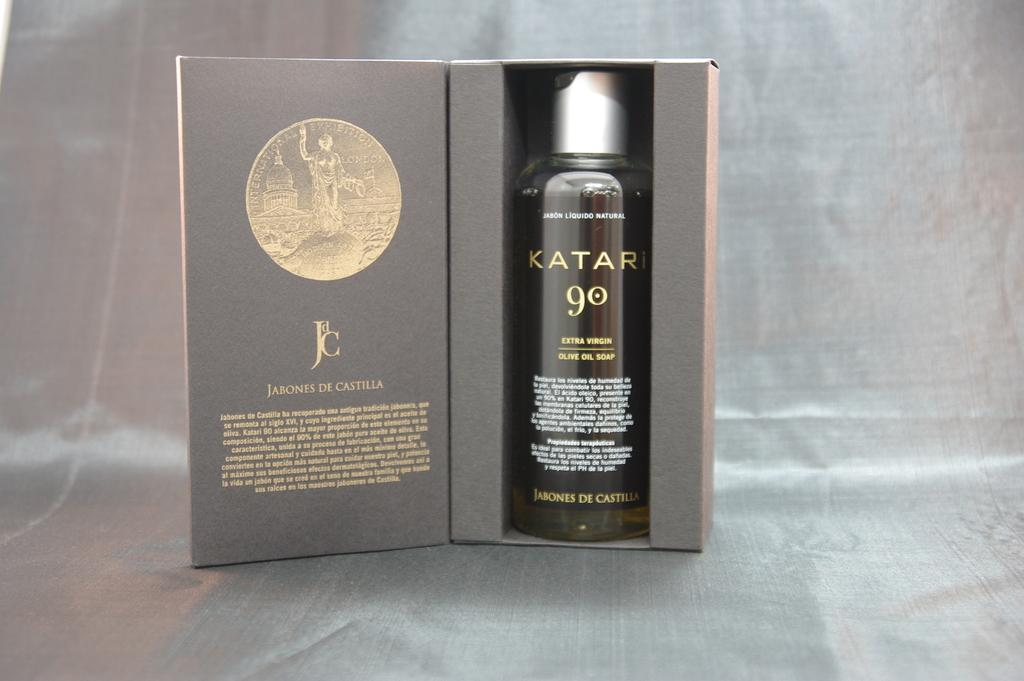<image>
Provide a brief description of the given image. A small, dark bottle of KATAR 90 sits in a box for presentation. 